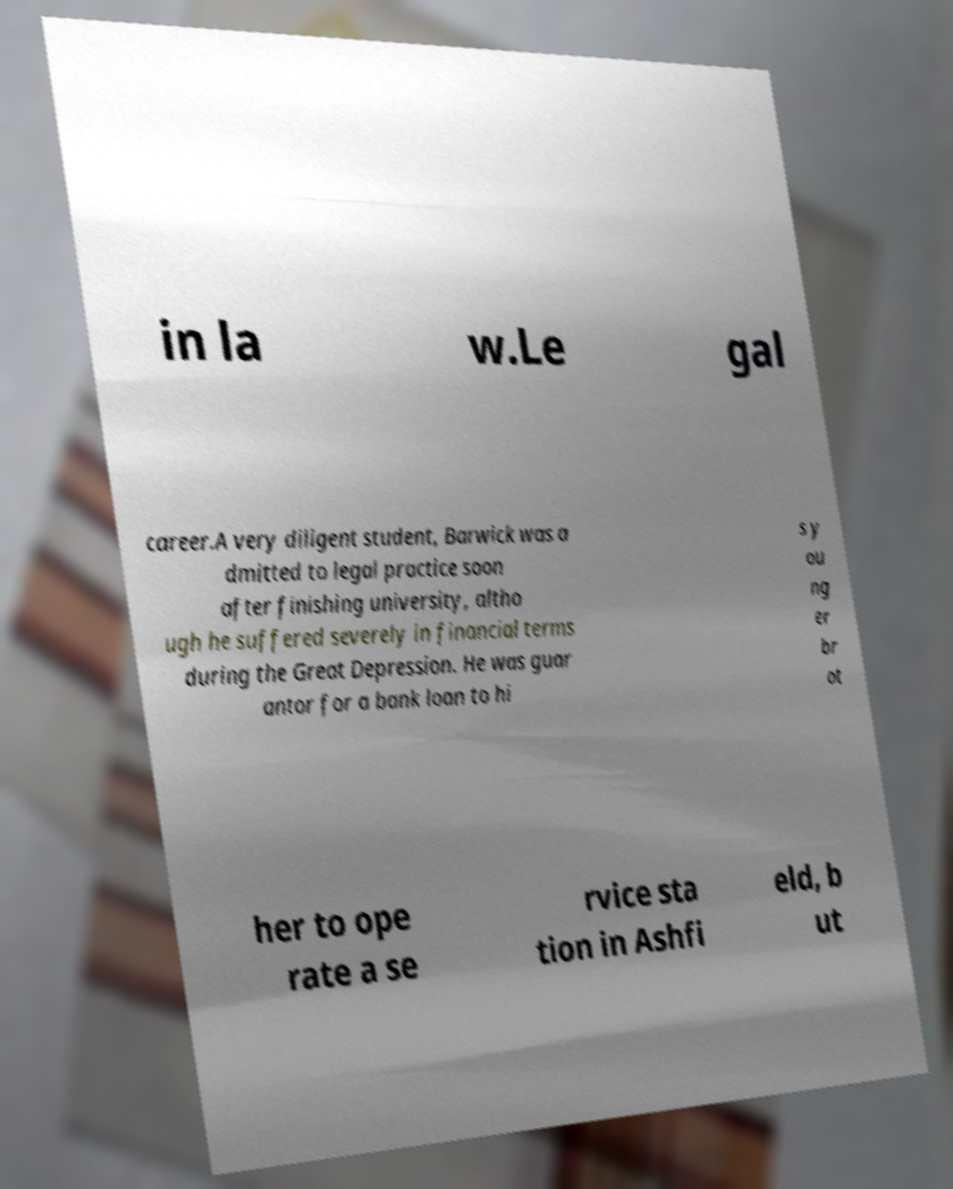For documentation purposes, I need the text within this image transcribed. Could you provide that? in la w.Le gal career.A very diligent student, Barwick was a dmitted to legal practice soon after finishing university, altho ugh he suffered severely in financial terms during the Great Depression. He was guar antor for a bank loan to hi s y ou ng er br ot her to ope rate a se rvice sta tion in Ashfi eld, b ut 